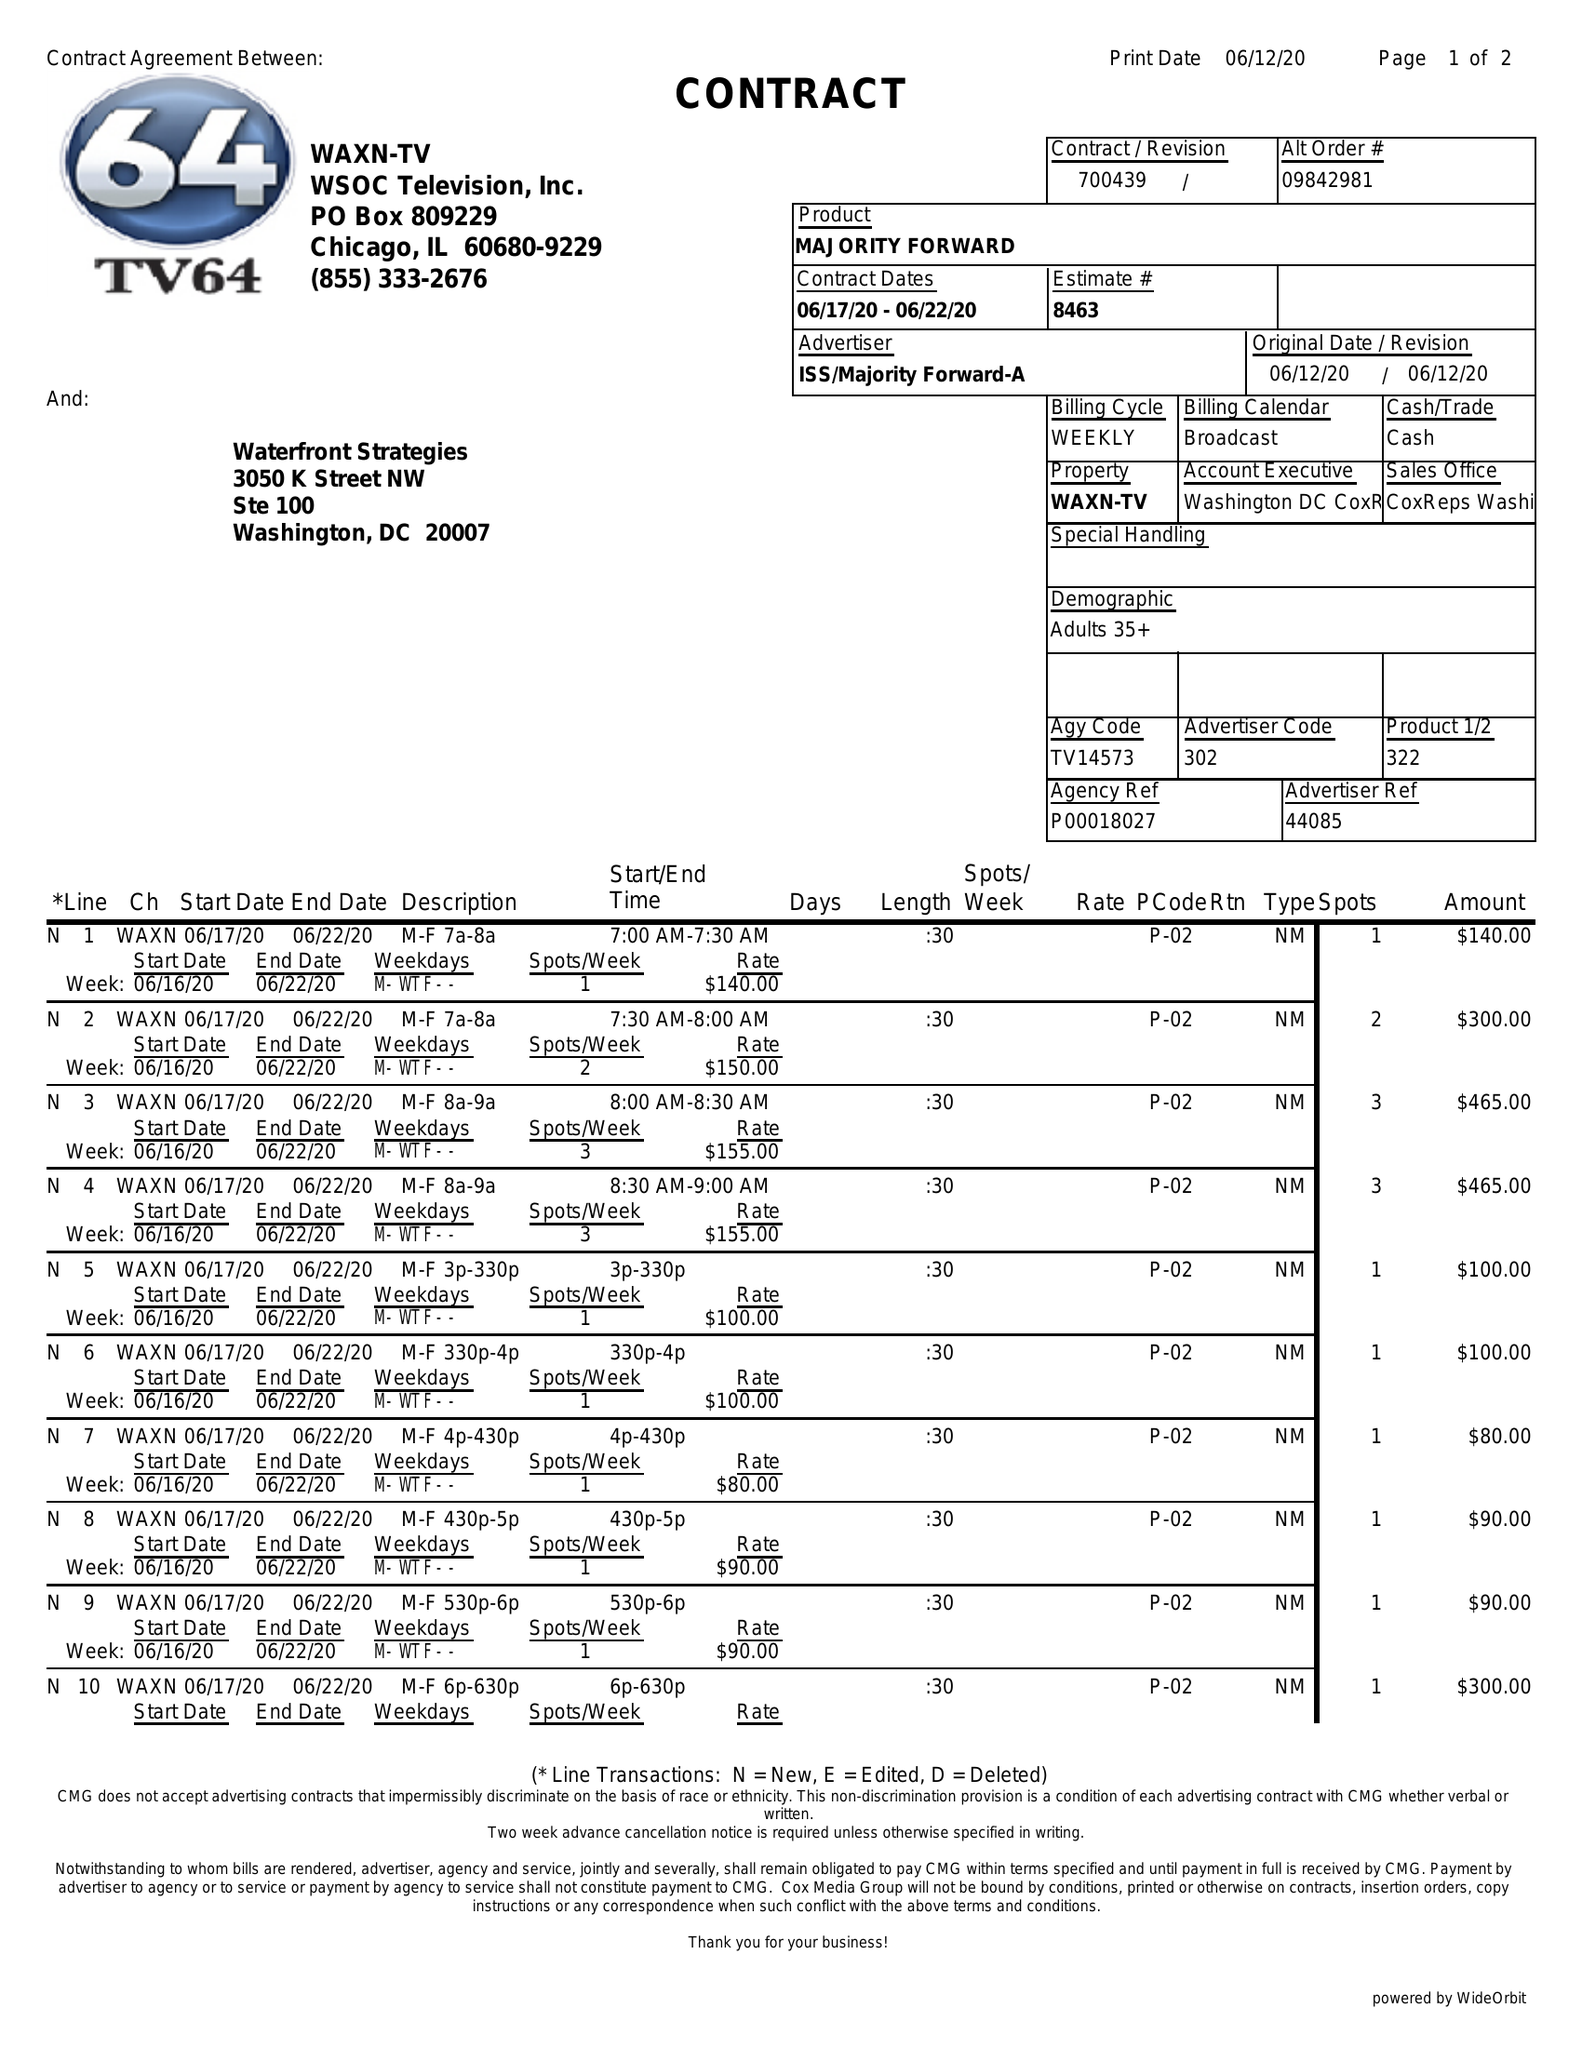What is the value for the flight_to?
Answer the question using a single word or phrase. 06/22/20 